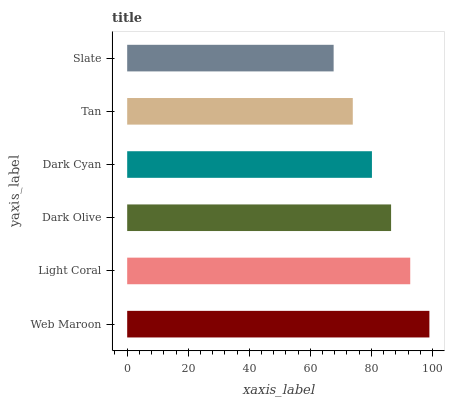Is Slate the minimum?
Answer yes or no. Yes. Is Web Maroon the maximum?
Answer yes or no. Yes. Is Light Coral the minimum?
Answer yes or no. No. Is Light Coral the maximum?
Answer yes or no. No. Is Web Maroon greater than Light Coral?
Answer yes or no. Yes. Is Light Coral less than Web Maroon?
Answer yes or no. Yes. Is Light Coral greater than Web Maroon?
Answer yes or no. No. Is Web Maroon less than Light Coral?
Answer yes or no. No. Is Dark Olive the high median?
Answer yes or no. Yes. Is Dark Cyan the low median?
Answer yes or no. Yes. Is Dark Cyan the high median?
Answer yes or no. No. Is Light Coral the low median?
Answer yes or no. No. 